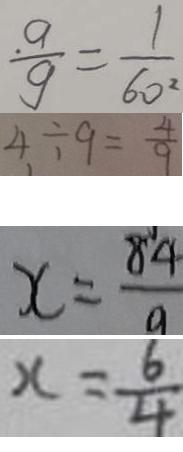Convert formula to latex. <formula><loc_0><loc_0><loc_500><loc_500>\frac { a } { g } = \frac { 1 } { 6 0 ^ { 2 } } 
 4 \div 9 = \frac { 4 } { 9 } 
 x = \frac { 8 4 } { 9 } 
 x = \frac { 6 } { 4 }</formula> 